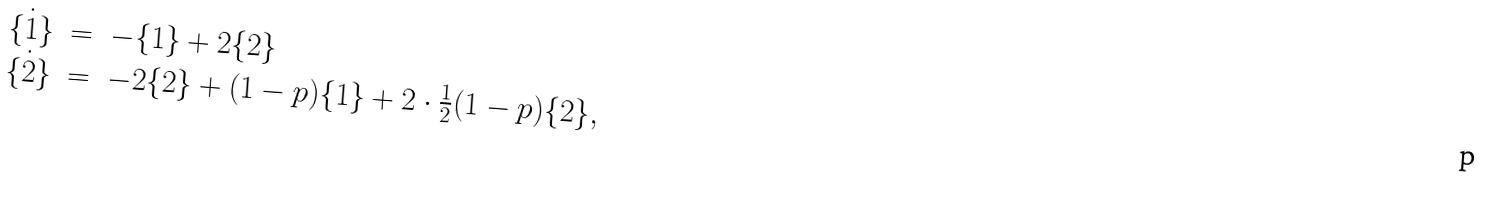Convert formula to latex. <formula><loc_0><loc_0><loc_500><loc_500>\begin{array} { r c l } \dot { \{ 1 \} } & = & - \{ 1 \} + 2 \{ 2 \} \\ \dot { \{ 2 \} } & = & - 2 \{ 2 \} + ( 1 - p ) \{ 1 \} + 2 \cdot \frac { 1 } { 2 } ( 1 - p ) \{ 2 \} , \end{array}</formula> 